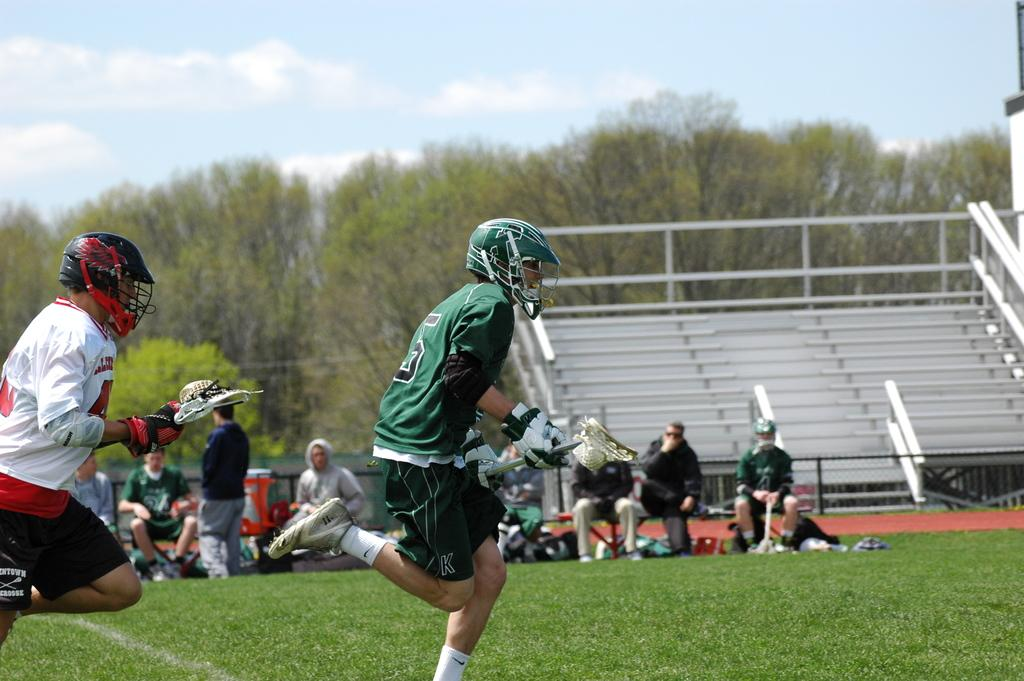What is happening with the people in the image? There are people on the ground in the image. What can be seen on the right side of the image? There are stairs on the right side of the image. What type of natural elements are visible in the background of the image? There are trees in the background of the image. What is visible in the sky in the background of the image? There are clouds in the sky in the background of the image. What type of beef is being served on the stairs in the image? There is no beef present in the image; it features people on the ground, stairs, trees, and clouds. 